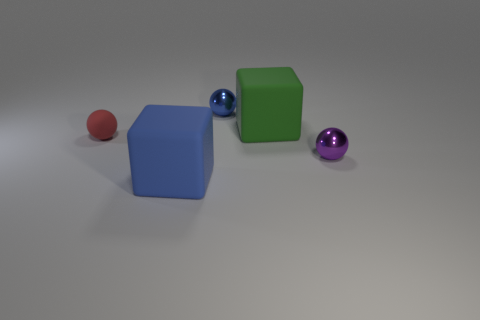Subtract all tiny shiny spheres. How many spheres are left? 1 Add 3 blue matte things. How many objects exist? 8 Subtract all balls. How many objects are left? 2 Add 1 small purple metallic balls. How many small purple metallic balls exist? 2 Subtract 1 purple balls. How many objects are left? 4 Subtract all tiny purple things. Subtract all red cubes. How many objects are left? 4 Add 3 tiny metallic things. How many tiny metallic things are left? 5 